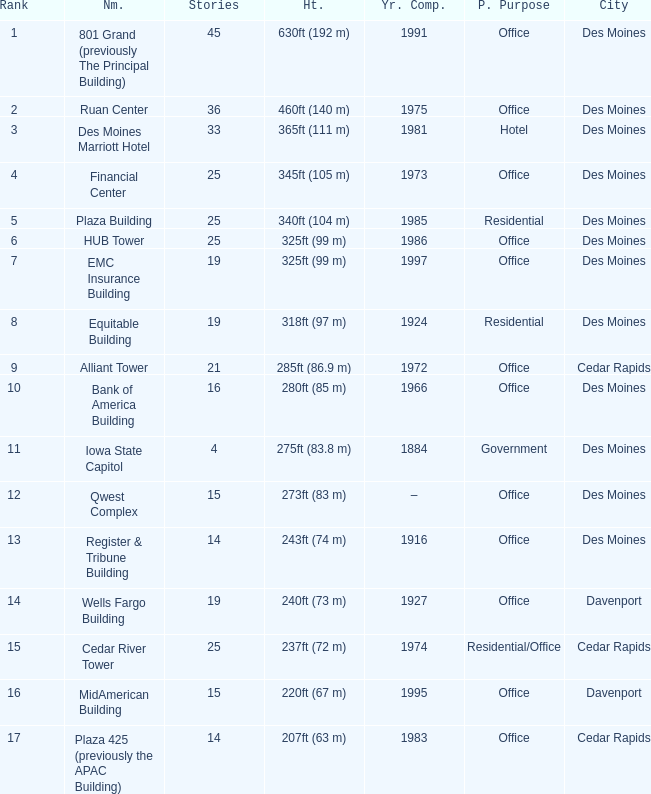What is the cumulative number of stories ranking at 10? 1.0. 